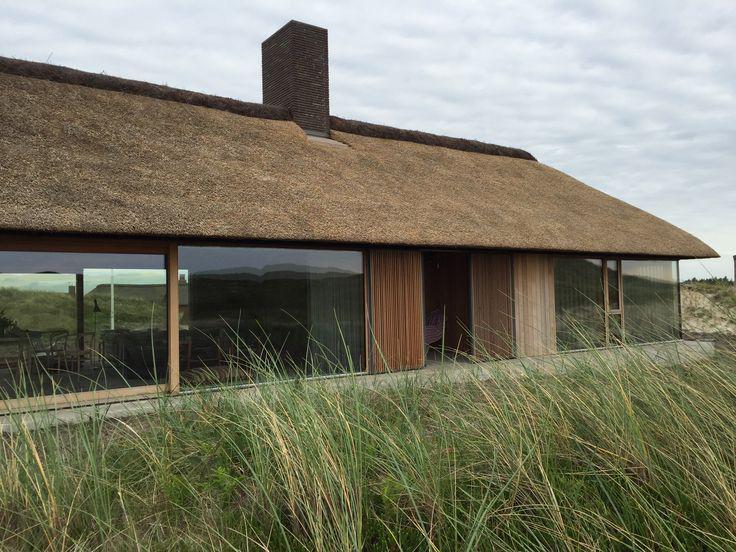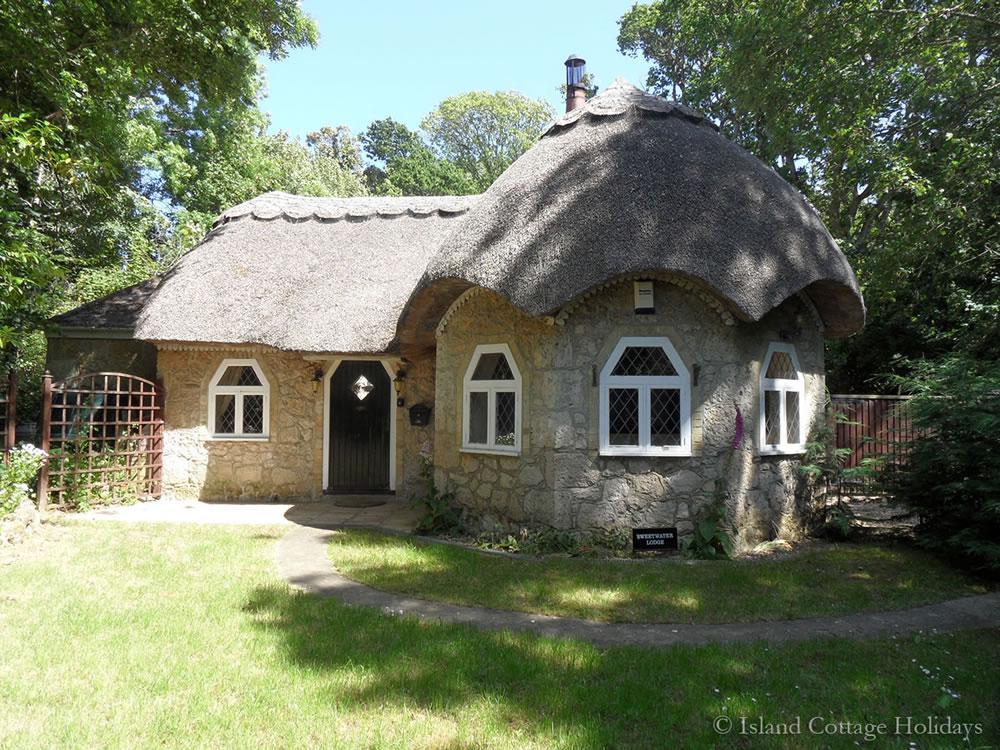The first image is the image on the left, the second image is the image on the right. Given the left and right images, does the statement "The left and right image contains the same number of homes with one story of windows." hold true? Answer yes or no. Yes. The first image is the image on the left, the second image is the image on the right. Evaluate the accuracy of this statement regarding the images: "The right image shows a house with windows featuring different shaped panes below a thick gray roof with a rounded section in front and a scalloped border on the peak edge.". Is it true? Answer yes or no. Yes. 